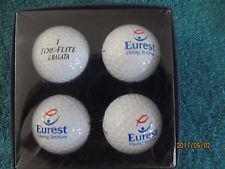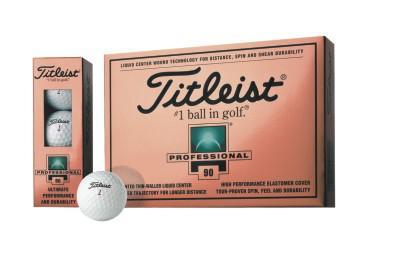The first image is the image on the left, the second image is the image on the right. For the images displayed, is the sentence "All of the golf balls are inside boxes." factually correct? Answer yes or no. No. The first image is the image on the left, the second image is the image on the right. Assess this claim about the two images: "An image includes at least one golf ball out of its package, next to a box made to hold a few balls.". Correct or not? Answer yes or no. Yes. 